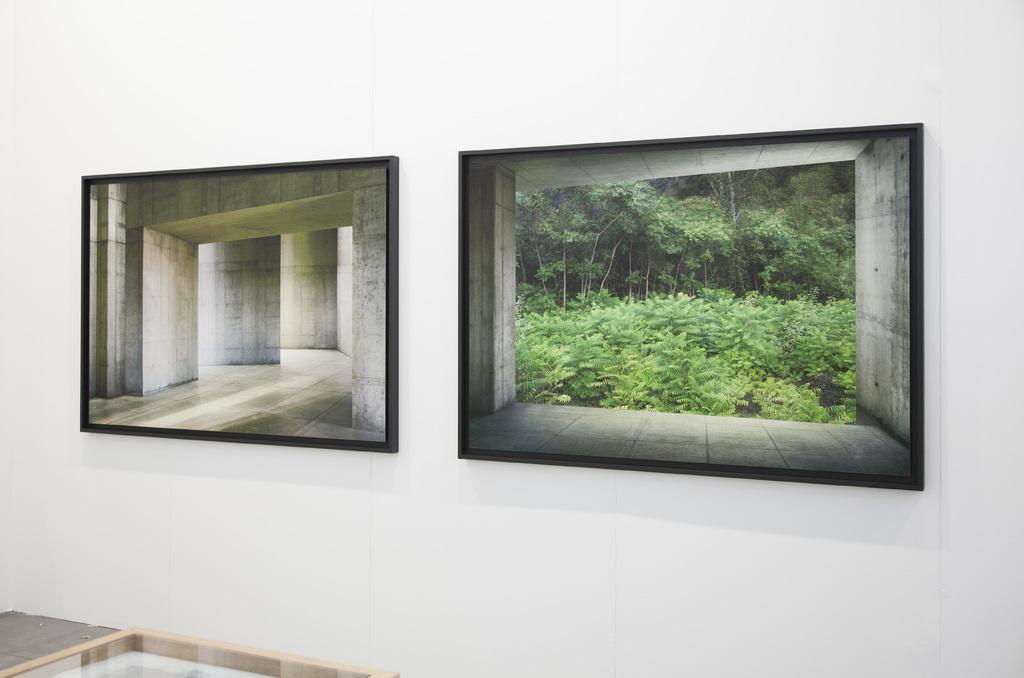How would you summarize this image in a sentence or two? In this image I see the white wall on which there are 2 frames in which I see the picture of the walls in this frame and I see the picture of plants and trees in this frame. 